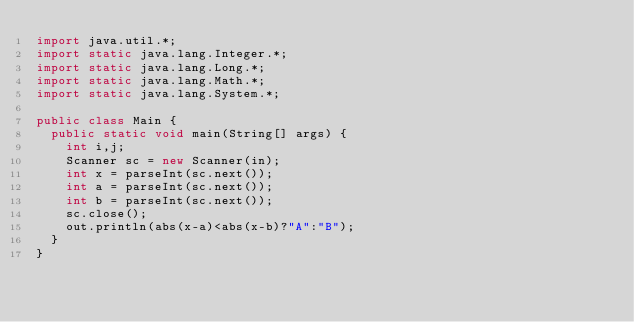<code> <loc_0><loc_0><loc_500><loc_500><_Java_>import java.util.*;
import static java.lang.Integer.*;
import static java.lang.Long.*;
import static java.lang.Math.*;
import static java.lang.System.*;

public class Main {
	public static void main(String[] args) {
		int i,j;
		Scanner sc = new Scanner(in);
		int x = parseInt(sc.next());
		int a = parseInt(sc.next());
		int b = parseInt(sc.next());
		sc.close();
		out.println(abs(x-a)<abs(x-b)?"A":"B");
	}
}
</code> 